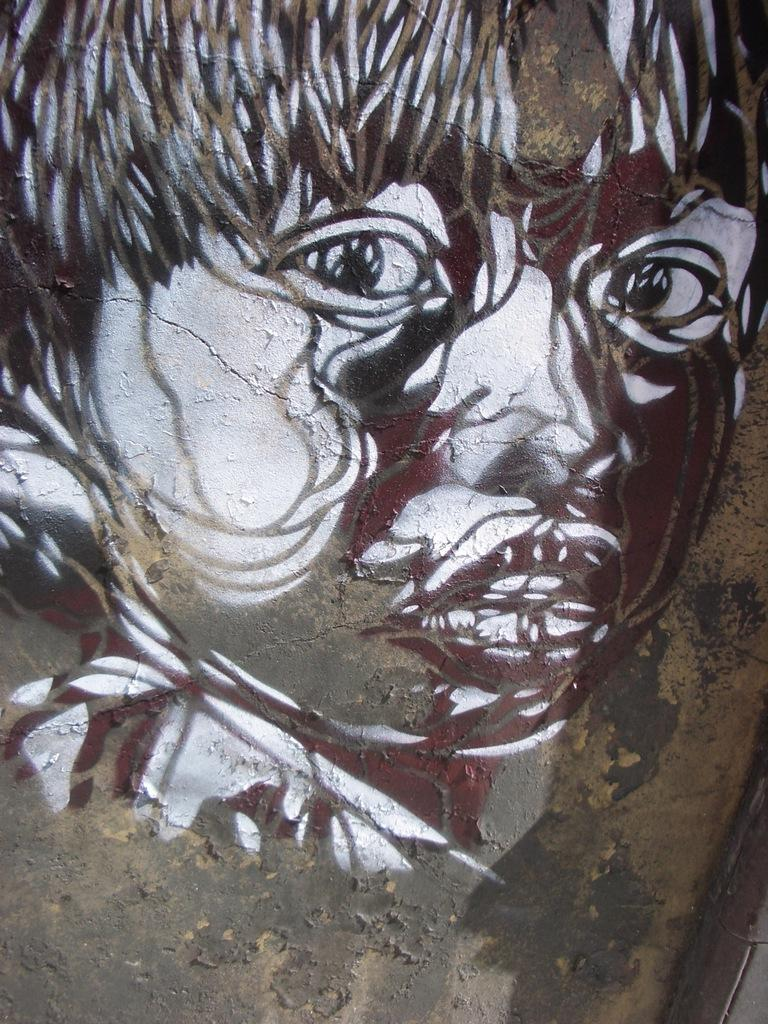What is the main subject of the image? There is a painting in the image. What does the painting depict? The painting depicts a person's face. Where is the painting located? The painting is on a surface. What type of playground equipment can be seen in the painting? There is no playground equipment present in the painting; it depicts a person's face. How many times does the person in the painting jump in the image? The person in the painting does not jump in the image; they are depicted in a static pose. 